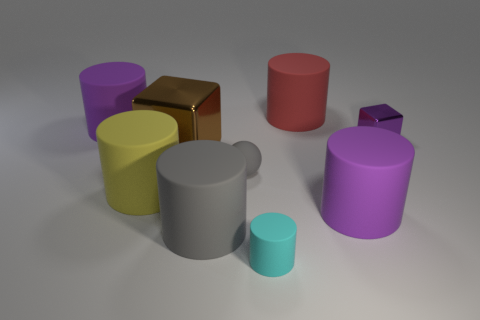Subtract all purple cylinders. How many cylinders are left? 4 Subtract all gray cylinders. How many cylinders are left? 5 Subtract all brown cylinders. Subtract all blue cubes. How many cylinders are left? 6 Add 1 small gray objects. How many objects exist? 10 Subtract all cubes. How many objects are left? 7 Subtract all yellow cylinders. Subtract all yellow cylinders. How many objects are left? 7 Add 4 tiny gray matte things. How many tiny gray matte things are left? 5 Add 8 large brown cubes. How many large brown cubes exist? 9 Subtract 0 cyan blocks. How many objects are left? 9 